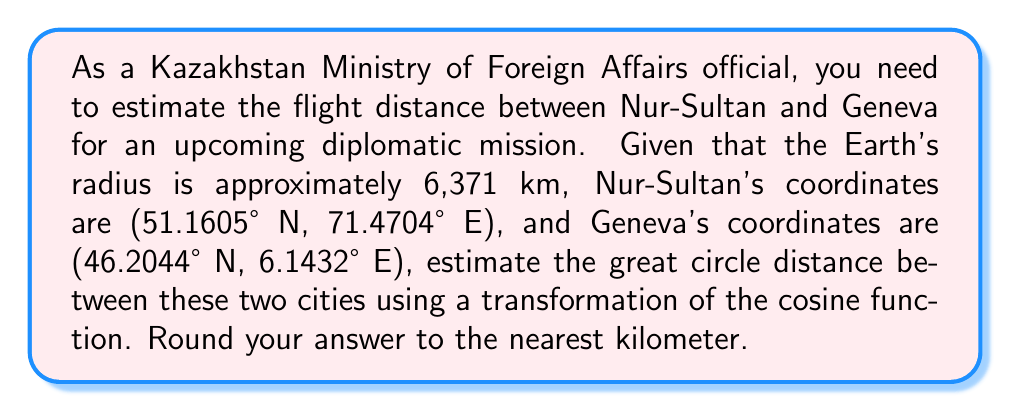Provide a solution to this math problem. To solve this problem, we'll use the great circle distance formula and apply a transformation to the cosine function. Let's break it down step-by-step:

1) The great circle distance formula is:
   $$d = R \cdot \arccos(\sin(\phi_1) \sin(\phi_2) + \cos(\phi_1) \cos(\phi_2) \cos(\Delta \lambda))$$
   where $R$ is the Earth's radius, $\phi_1$ and $\phi_2$ are the latitudes, and $\Delta \lambda$ is the difference in longitudes.

2) Convert the coordinates to radians:
   Nur-Sultan: $\phi_1 = 51.1605° \cdot \frac{\pi}{180} = 0.8929$ rad
               $\lambda_1 = 71.4704° \cdot \frac{\pi}{180} = 1.2471$ rad
   Geneva: $\phi_2 = 46.2044° \cdot \frac{\pi}{180} = 0.8064$ rad
           $\lambda_2 = 6.1432° \cdot \frac{\pi}{180} = 0.1072$ rad

3) Calculate $\Delta \lambda$:
   $\Delta \lambda = \lambda_1 - \lambda_2 = 1.2471 - 0.1072 = 1.1399$ rad

4) Apply the formula:
   $$\begin{align}
   d &= 6371 \cdot \arccos(\sin(0.8929) \sin(0.8064) + \cos(0.8929) \cos(0.8064) \cos(1.1399)) \\
   &= 6371 \cdot \arccos(0.7791 + 0.1539) \\
   &= 6371 \cdot \arccos(0.9330) \\
   &= 6371 \cdot 0.3673 \\
   &= 2340.0683 \text{ km}
   \end{align}$$

5) Rounding to the nearest kilometer:
   $d \approx 2340$ km

The transformation applied here is the composition of the arccosine function with the cosine function inside the great circle distance formula. This transformation allows us to convert the angular distance on a sphere to a linear distance along its surface.
Answer: 2340 km 